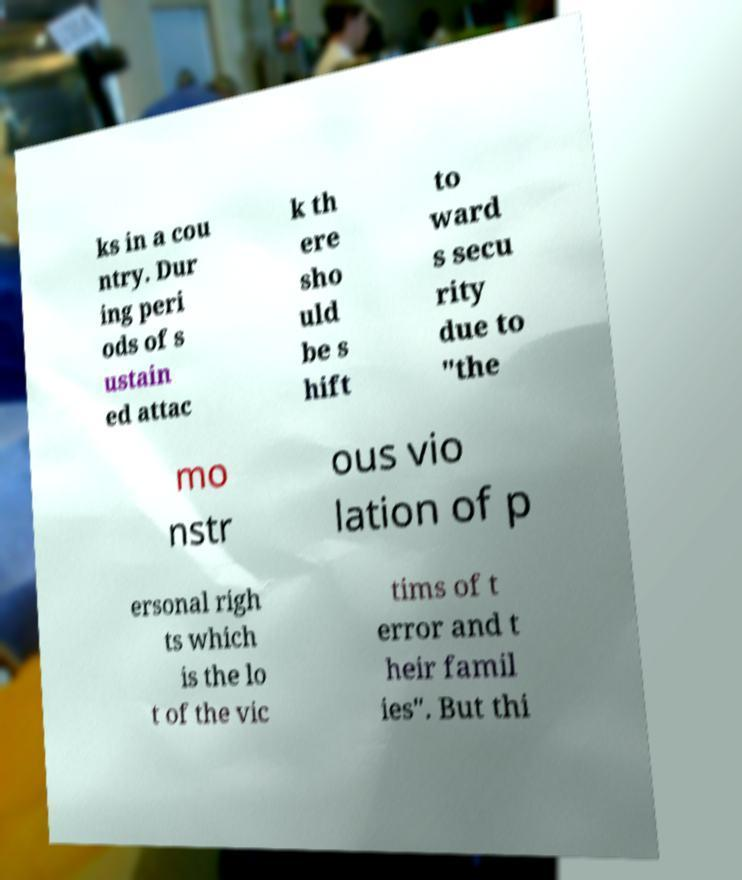Can you accurately transcribe the text from the provided image for me? ks in a cou ntry. Dur ing peri ods of s ustain ed attac k th ere sho uld be s hift to ward s secu rity due to "the mo nstr ous vio lation of p ersonal righ ts which is the lo t of the vic tims of t error and t heir famil ies". But thi 